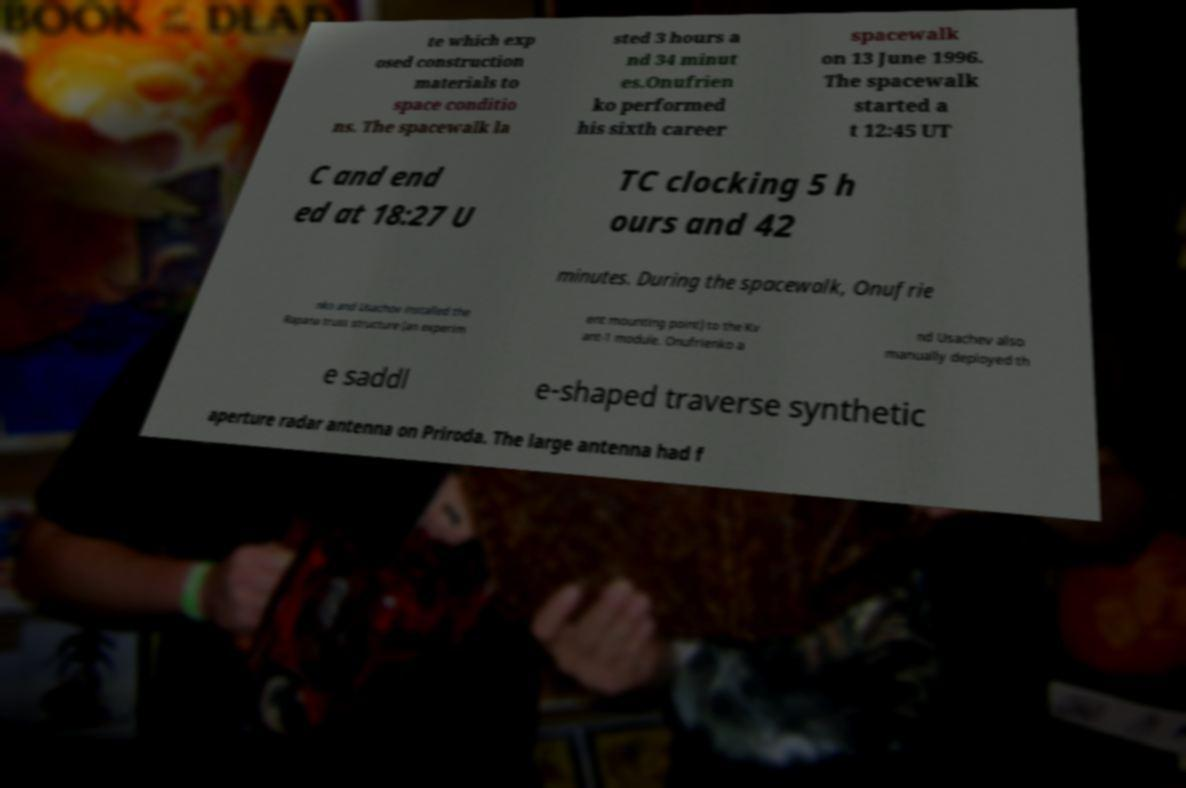Please read and relay the text visible in this image. What does it say? te which exp osed construction materials to space conditio ns. The spacewalk la sted 3 hours a nd 34 minut es.Onufrien ko performed his sixth career spacewalk on 13 June 1996. The spacewalk started a t 12:45 UT C and end ed at 18:27 U TC clocking 5 h ours and 42 minutes. During the spacewalk, Onufrie nko and Usachov installed the Rapana truss structure (an experim ent mounting point) to the Kv ant-1 module. Onufrienko a nd Usachev also manually deployed th e saddl e-shaped traverse synthetic aperture radar antenna on Priroda. The large antenna had f 